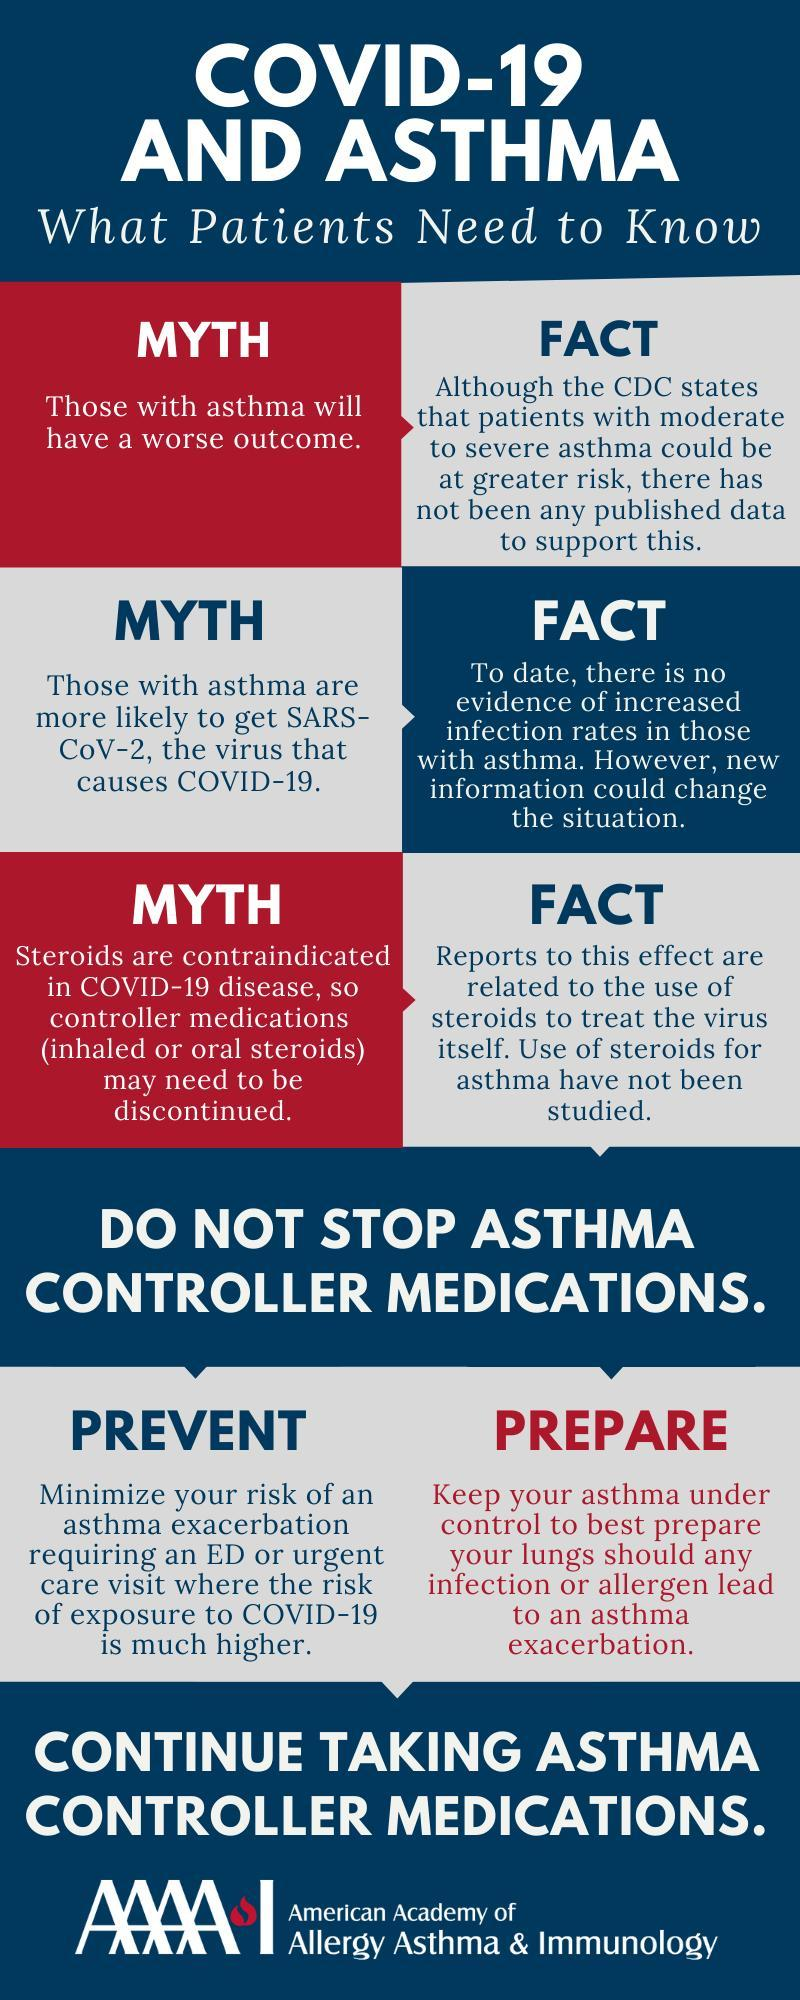How many myths have been listed in the infographic?
Answer the question with a short phrase. 3 What is the main message projected in the infographic by the American Academy of Allergy Asthma & Immunology? Continue taking asthma controller medications 